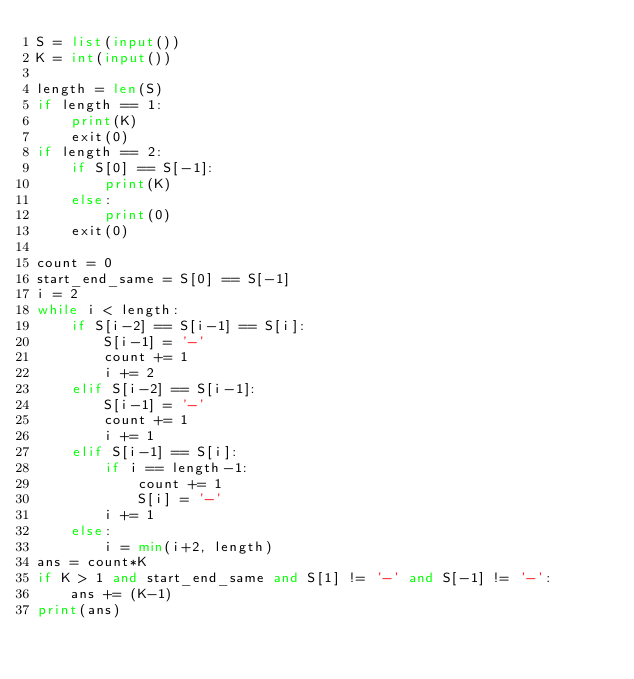Convert code to text. <code><loc_0><loc_0><loc_500><loc_500><_Python_>S = list(input())
K = int(input())

length = len(S)
if length == 1:
    print(K)
    exit(0)
if length == 2:
    if S[0] == S[-1]:
        print(K)
    else:
        print(0)
    exit(0)

count = 0
start_end_same = S[0] == S[-1]
i = 2
while i < length:
    if S[i-2] == S[i-1] == S[i]:
        S[i-1] = '-'
        count += 1
        i += 2
    elif S[i-2] == S[i-1]:
        S[i-1] = '-'
        count += 1
        i += 1
    elif S[i-1] == S[i]:
        if i == length-1:
            count += 1
            S[i] = '-'
        i += 1
    else:
        i = min(i+2, length)
ans = count*K
if K > 1 and start_end_same and S[1] != '-' and S[-1] != '-':
    ans += (K-1)
print(ans)</code> 